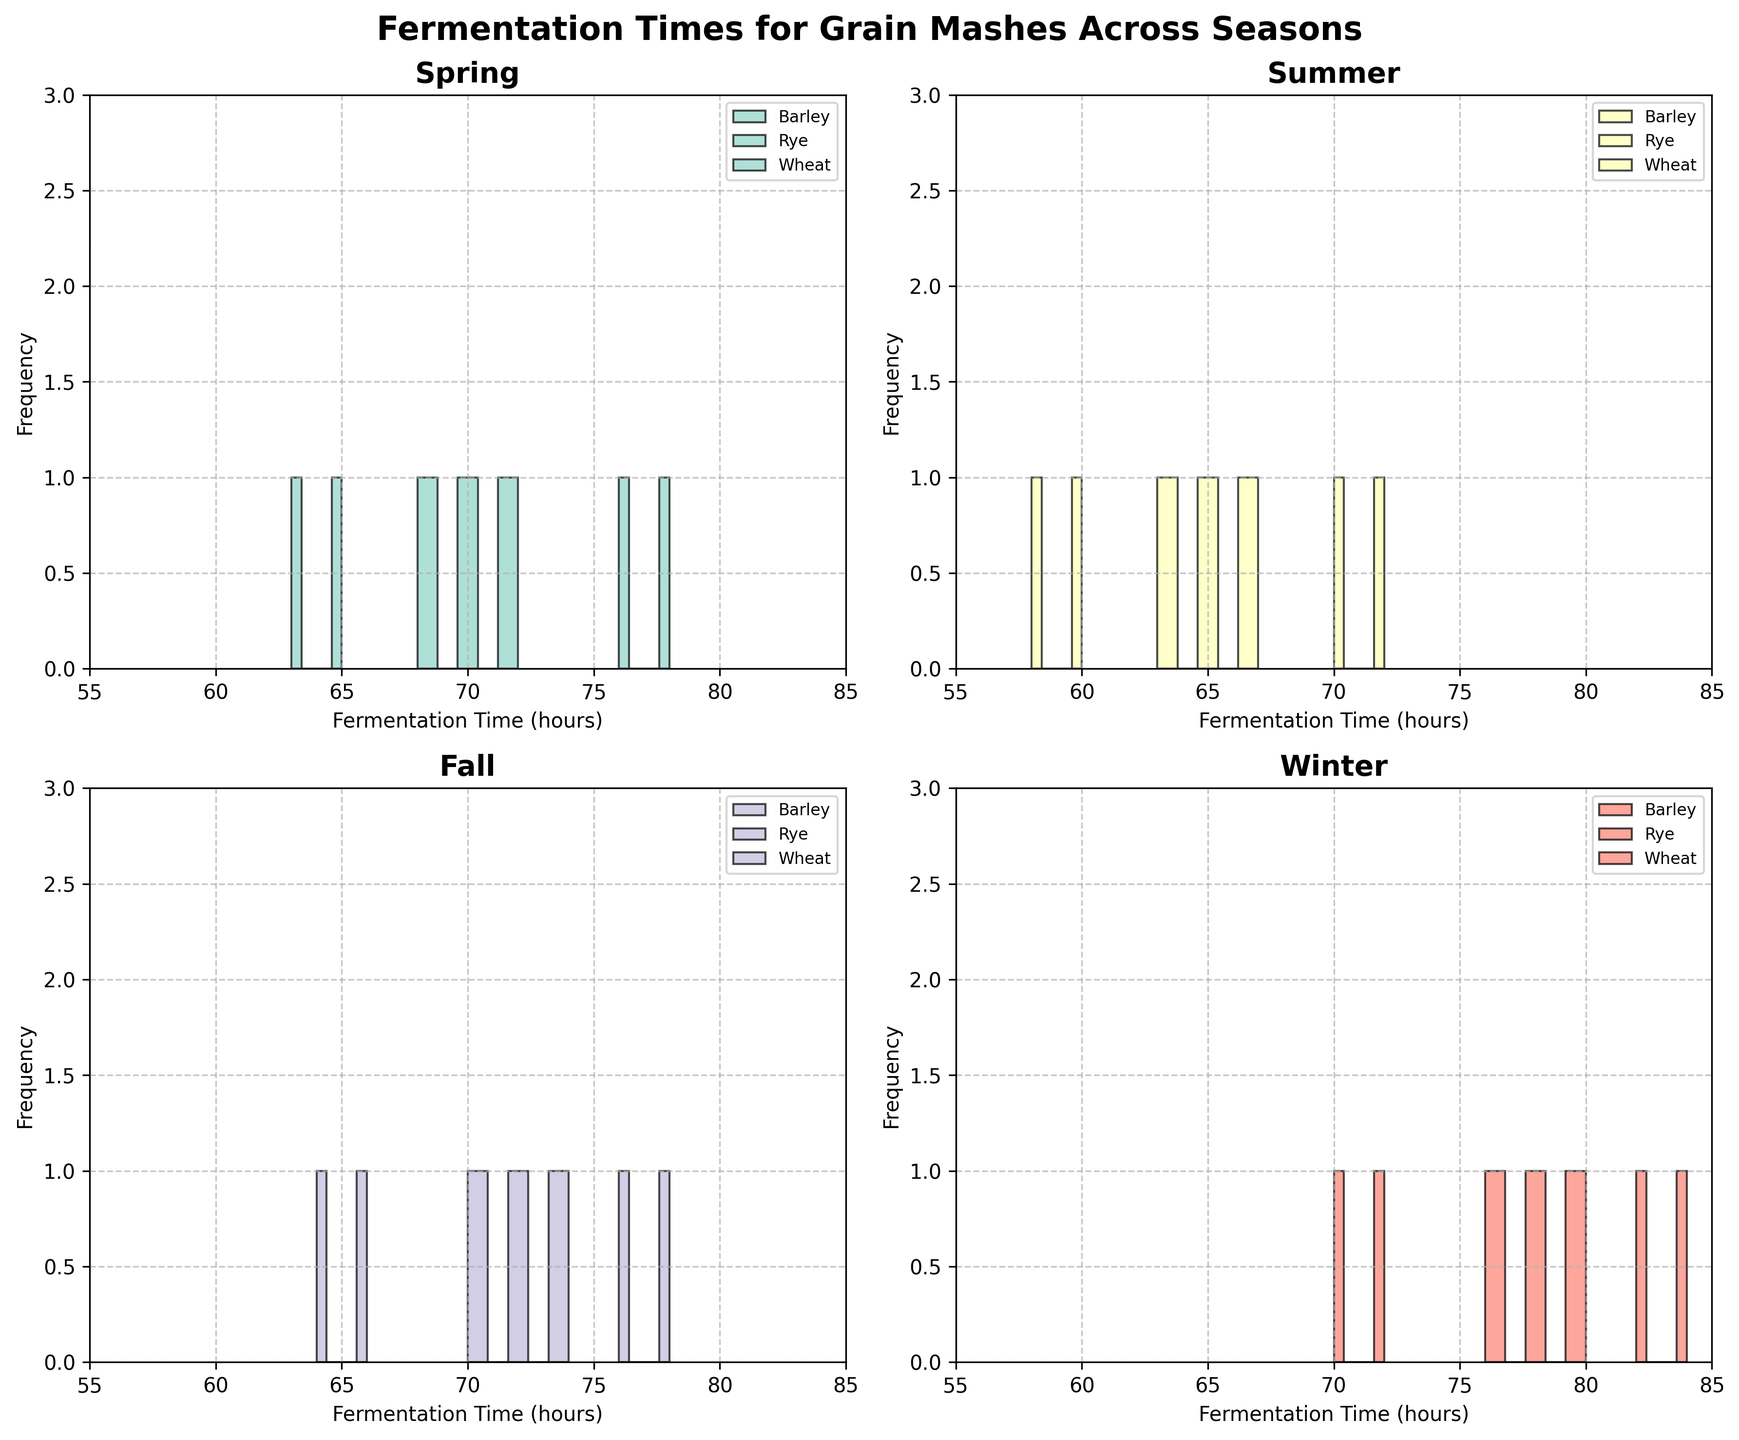How many different grain types are displayed in the Winter subplot? The Winter subplot shows histograms for three different grain types: Barley, Rye, and Wheat as per the colors and labels used.
Answer: 3 Which season has the highest fermentation times for Barley? Looking at the highest bars in the Barley histograms, Winter shows the highest fermentation times, with fermentation times reaching up to 80 hours.
Answer: Winter What is the range of fermentation times for Wheat in Summer? In the Summer subplot, the fermentation times for Wheat range from 58 to 60 hours as observed from the histogram bars.
Answer: 58 to 60 Across all seasons, which grain and season combination has the widest range of fermentation times? Comparing the width of the histograms across all subplots and grains, Barley in Winter has the widest range, spanning from 76 to 80 hours.
Answer: Barley in Winter How many total fermentation time data points are there for Rye in Fall? By looking at the histogram bars for Rye in the Fall subplot, there are two bars, each representing a frequency of 1, indicating two data points.
Answer: 2 Between Spring and Fall, which season has higher average fermentation times for Barley? Spring has fermentation times of 72, 68, and 70 for Barley, while Fall has 70, 72, and 74. The average for Spring is (72+68+70)/3 = 70 and for Fall (70+72+74)/3 ≈ 72. Thus, Fall has higher average fermentation times.
Answer: Fall Which season shows the most consistent fermentation times for Wheat? Consistency can be inferred from less spread in the histogram bars. Summer shows two narrow bars at 58 and 60, indicating the least variation.
Answer: Summer What unique observation can be made about Rye fermentation times in Winter compared to other seasons? Rye in Winter has the distinct characteristic that the fermentation times peak around 82 to 84 hours, which is significantly higher compared to other seasons where they peak around mid-70s.
Answer: Higher peak in Winter What common range of fermentation times do Wheat and Barley share in Spring? The Spring subplot histograms for Wheat (63 and 65) and Barley (68, 70, 72) share a common range in the 65-hour area.
Answer: Around 65 hours Looking at all four subplots, during which season is there the largest number of data points for any single grain? Across all seasons and grains, Winter's Barley has the most data points, shown by the three bars in the 76-80 hour range.
Answer: Winter's Barley 